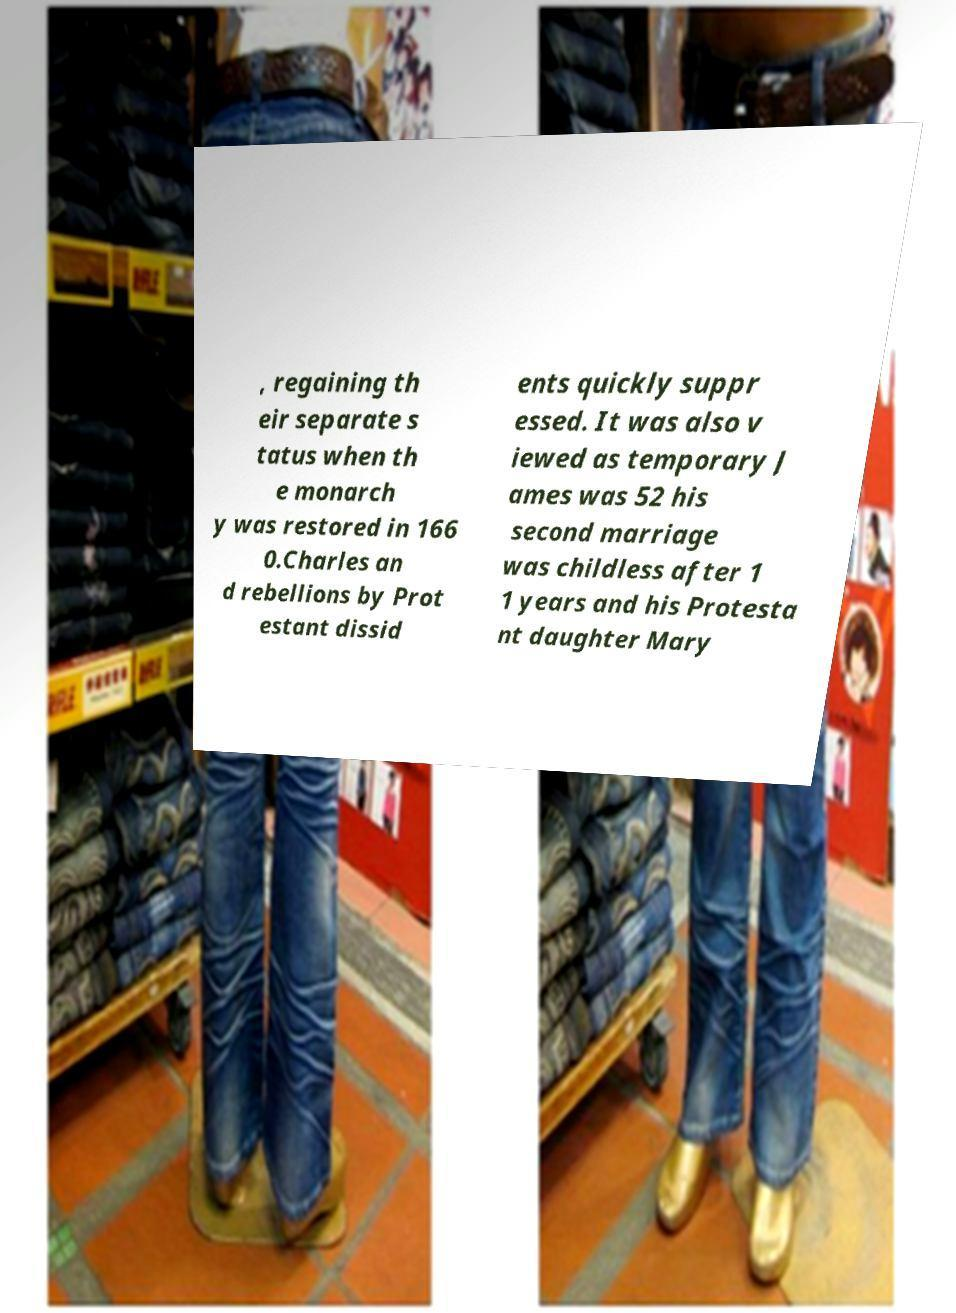I need the written content from this picture converted into text. Can you do that? , regaining th eir separate s tatus when th e monarch y was restored in 166 0.Charles an d rebellions by Prot estant dissid ents quickly suppr essed. It was also v iewed as temporary J ames was 52 his second marriage was childless after 1 1 years and his Protesta nt daughter Mary 